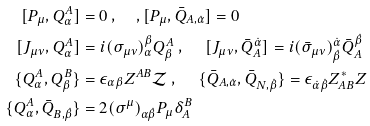Convert formula to latex. <formula><loc_0><loc_0><loc_500><loc_500>[ P _ { \mu } , Q _ { \alpha } ^ { A } ] & = 0 \text { , } \quad , [ P _ { \mu } , \bar { Q } _ { A , \dot { \alpha } } ] = 0 \\ [ J _ { \mu \nu } , Q _ { \alpha } ^ { A } ] & = i ( \sigma _ { \mu \nu } ) _ { \alpha } ^ { \beta } Q _ { \beta } ^ { A } \text { , } \quad \, [ J _ { \mu \nu } , \bar { Q } ^ { \dot { \alpha } } _ { A } ] = i ( \bar { \sigma } _ { \mu \nu } ) ^ { \dot { \alpha } } _ { \dot { \beta } } \bar { Q } ^ { \dot { \beta } } _ { A } \\ \{ Q _ { \alpha } ^ { A } , Q _ { \beta } ^ { B } \} & = \epsilon _ { \alpha \beta } Z ^ { A B } \mathcal { Z } \text { , } \quad \ \{ \bar { Q } _ { A , \dot { \alpha } } , \bar { Q } _ { N , \dot { \beta } } \} = \epsilon _ { \dot { \alpha } \dot { \beta } } Z ^ { * } _ { A B } Z \\ \{ Q _ { \alpha } ^ { A } , \bar { Q } _ { B , \dot { \beta } } \} & = 2 ( \sigma ^ { \mu } ) _ { \alpha \dot { \beta } } P _ { \mu } \delta _ { A } ^ { B }</formula> 